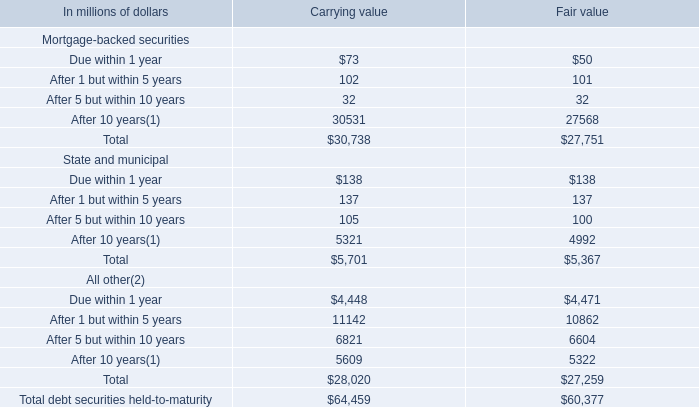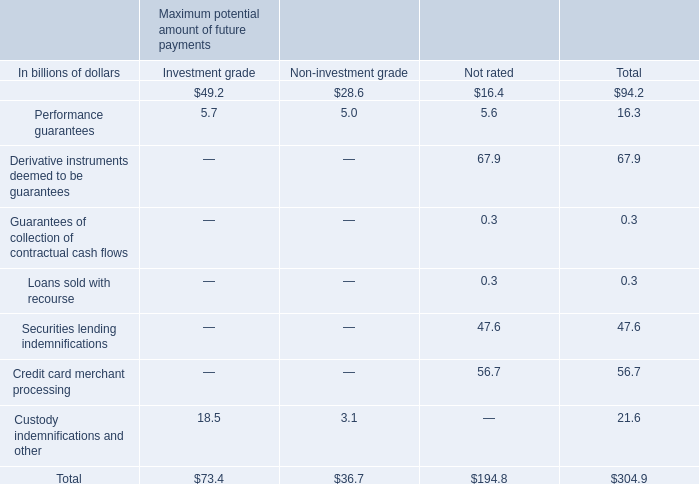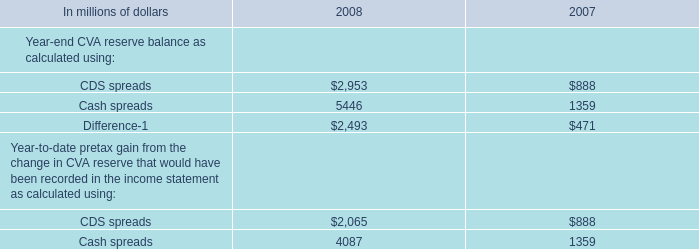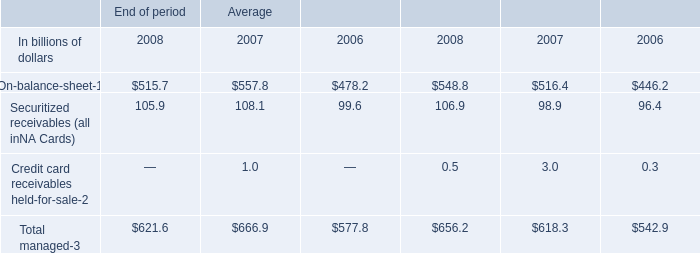What's the sum of Cash spreads of 2008, After 10 years State and municipal of Carrying value, and Difference of 2008 ? 
Computations: ((5446.0 + 5321.0) + 2493.0)
Answer: 13260.0. 